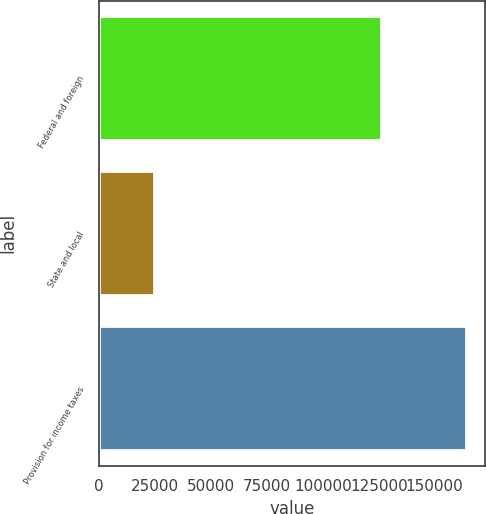Convert chart to OTSL. <chart><loc_0><loc_0><loc_500><loc_500><bar_chart><fcel>Federal and foreign<fcel>State and local<fcel>Provision for income taxes<nl><fcel>126075<fcel>24651<fcel>164098<nl></chart> 